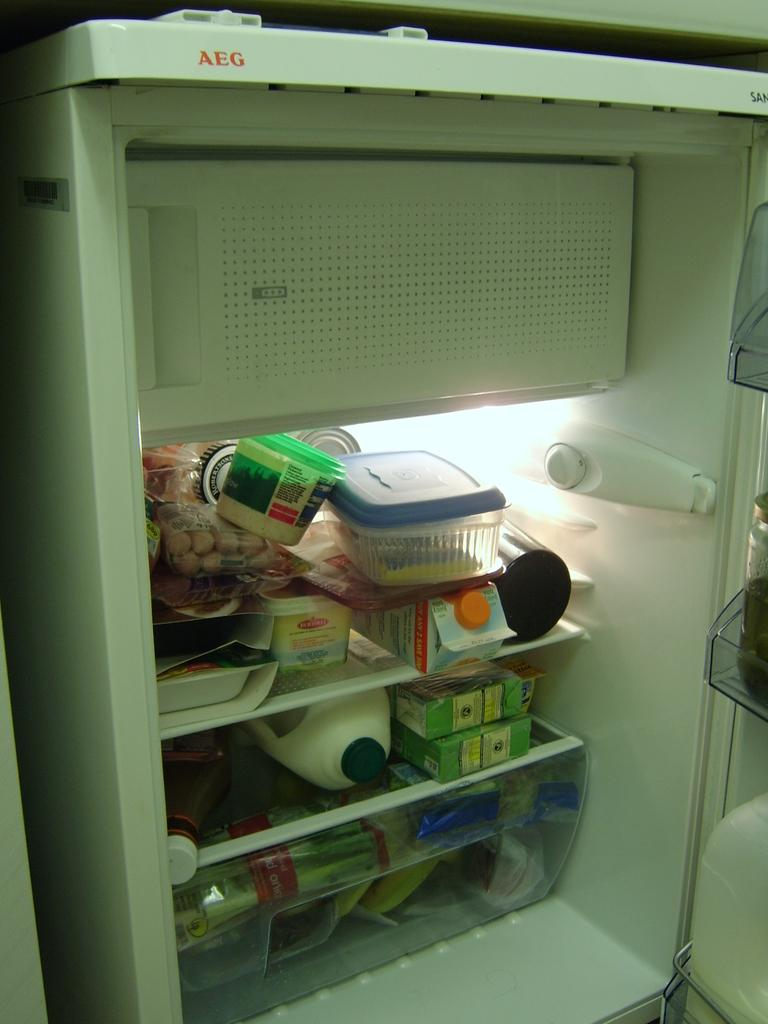What is the main object in the image? There is a milk can in the image. What else can be seen in the image besides the milk can? There are other food items in the image. Where are the food items located? The food items are inside a refrigerator. What religious beliefs are represented by the milk can in the image? The image does not depict any religious beliefs or symbols, and the milk can is not associated with any specific religion. 